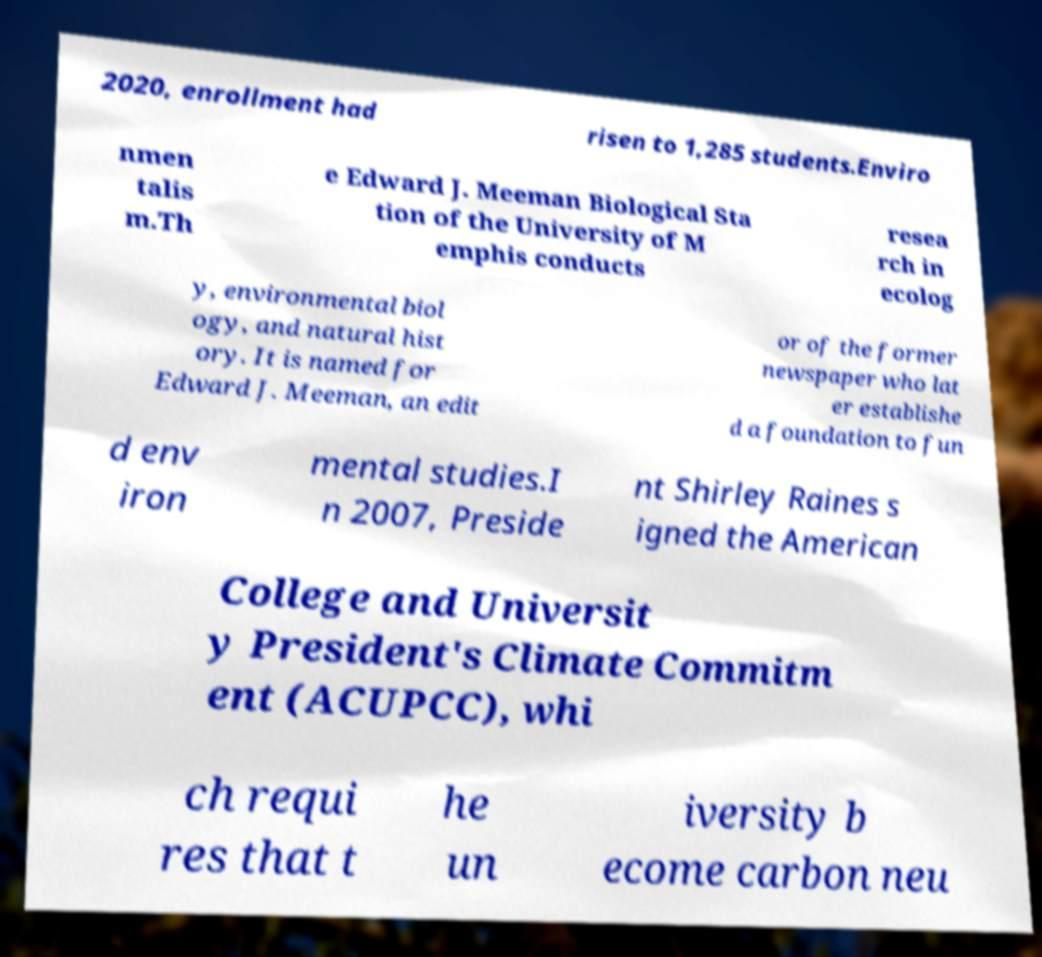I need the written content from this picture converted into text. Can you do that? 2020, enrollment had risen to 1,285 students.Enviro nmen talis m.Th e Edward J. Meeman Biological Sta tion of the University of M emphis conducts resea rch in ecolog y, environmental biol ogy, and natural hist ory. It is named for Edward J. Meeman, an edit or of the former newspaper who lat er establishe d a foundation to fun d env iron mental studies.I n 2007, Preside nt Shirley Raines s igned the American College and Universit y President's Climate Commitm ent (ACUPCC), whi ch requi res that t he un iversity b ecome carbon neu 